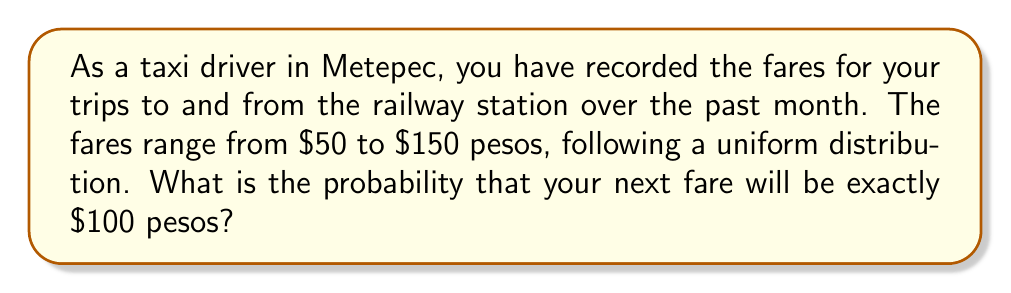Can you solve this math problem? To solve this problem, we need to consider the properties of a uniform distribution and apply the concept of probability in a continuous space.

1) In a uniform distribution, all outcomes within the range have equal probability.

2) The range of fares is from $50 to $150 pesos, so the total range is:
   $150 - $50 = $100 pesos

3) In a continuous uniform distribution, the probability of any exact value is technically zero. However, we can consider a small interval around $100, let's say ±$0.50.

4) The probability density function (PDF) for a uniform distribution is constant over its range and is given by:

   $$f(x) = \frac{1}{b-a}$$

   where $a$ is the minimum value and $b$ is the maximum value.

5) In this case:
   $$f(x) = \frac{1}{150-50} = \frac{1}{100} = 0.01$$

6) To find the probability of a fare being $100 ±$0.50, we calculate the area of this interval:

   $$P(99.50 \leq X \leq 100.50) = 0.01 * (100.50 - 99.50) = 0.01 * 1 = 0.01$$

Therefore, the probability of receiving exactly $100 (within a small practical interval) is 0.01 or 1%.
Answer: 0.01 or 1% 